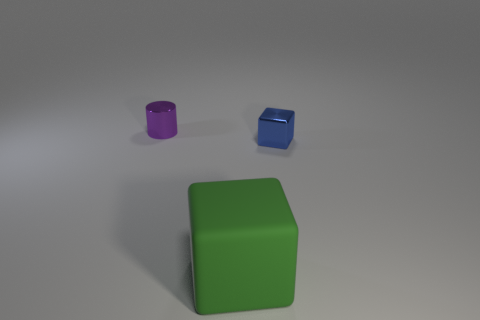Add 2 tiny brown rubber cylinders. How many objects exist? 5 Subtract all blue cubes. How many cubes are left? 1 Subtract all cylinders. How many objects are left? 2 Subtract 1 cubes. How many cubes are left? 1 Subtract all gray cylinders. Subtract all red cubes. How many cylinders are left? 1 Subtract all purple balls. How many green cylinders are left? 0 Subtract all small brown objects. Subtract all tiny blue blocks. How many objects are left? 2 Add 2 blue cubes. How many blue cubes are left? 3 Add 1 small green cylinders. How many small green cylinders exist? 1 Subtract 0 red blocks. How many objects are left? 3 